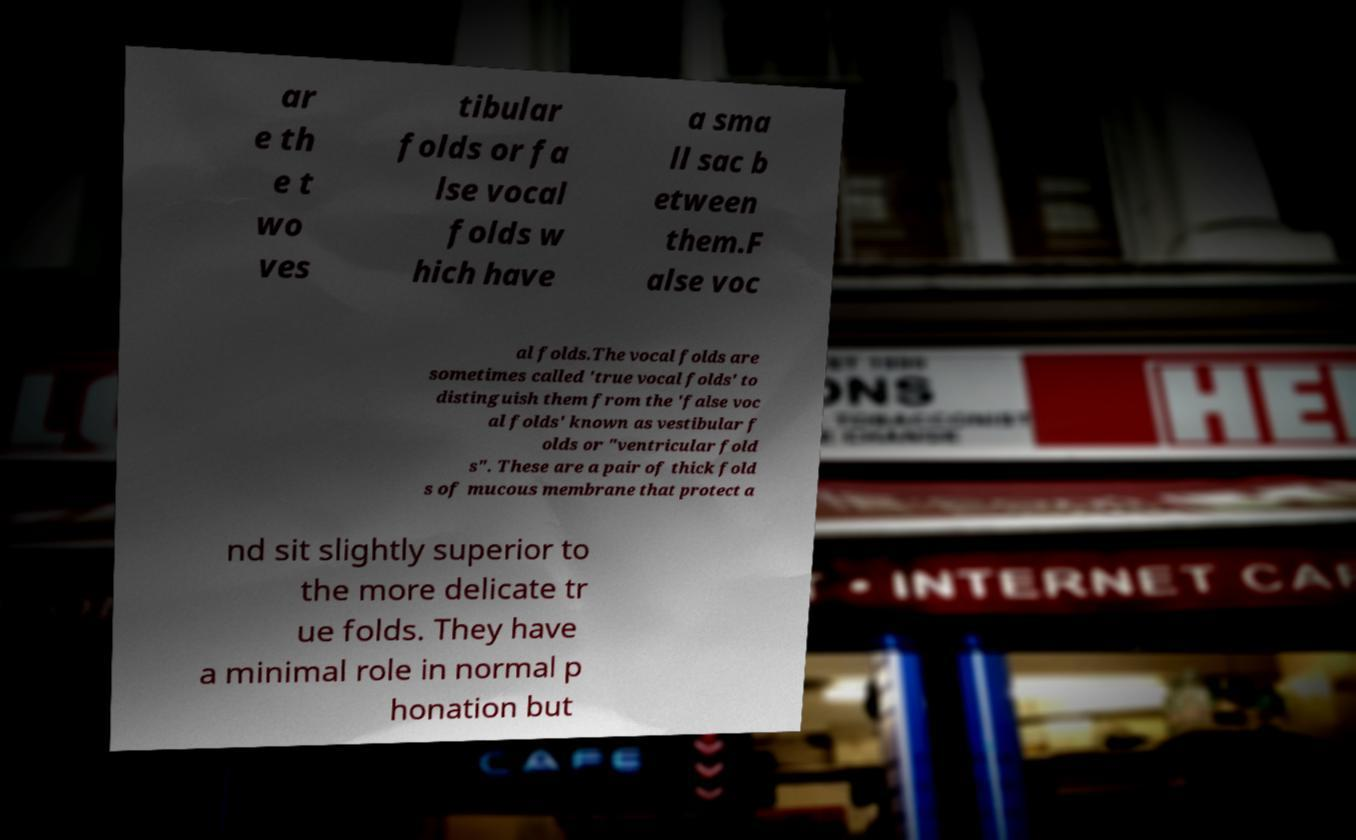Please read and relay the text visible in this image. What does it say? ar e th e t wo ves tibular folds or fa lse vocal folds w hich have a sma ll sac b etween them.F alse voc al folds.The vocal folds are sometimes called 'true vocal folds' to distinguish them from the 'false voc al folds' known as vestibular f olds or "ventricular fold s". These are a pair of thick fold s of mucous membrane that protect a nd sit slightly superior to the more delicate tr ue folds. They have a minimal role in normal p honation but 